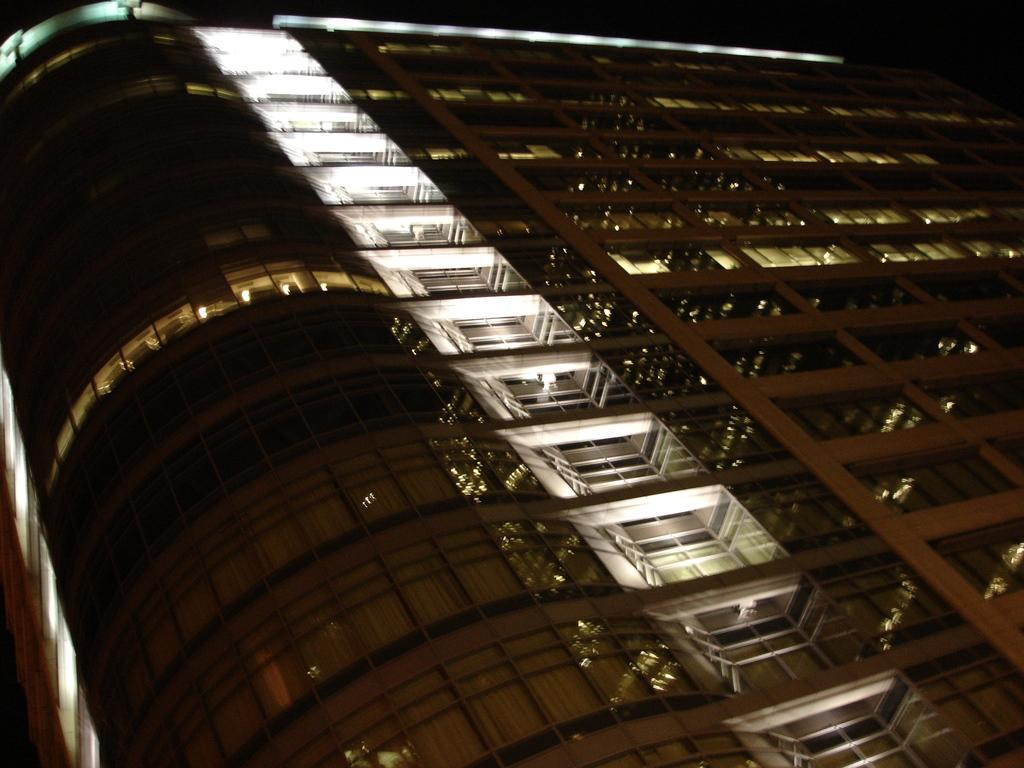What type of structure is in the image? There is a building in the image. What can be seen illuminated in the image? Lights are present in the image. What allows access to the building in the image? Doors are visible in the image. What provides a view of the outside from within the building in the image? Windows are present in the image. What forms the boundaries of the building in the image? Walls are visible in the image. Can you tell me how many yams are stored in the cellar of the building in the image? There is no cellar or yams mentioned in the image; it only features a building with lights, doors, windows, and walls. 